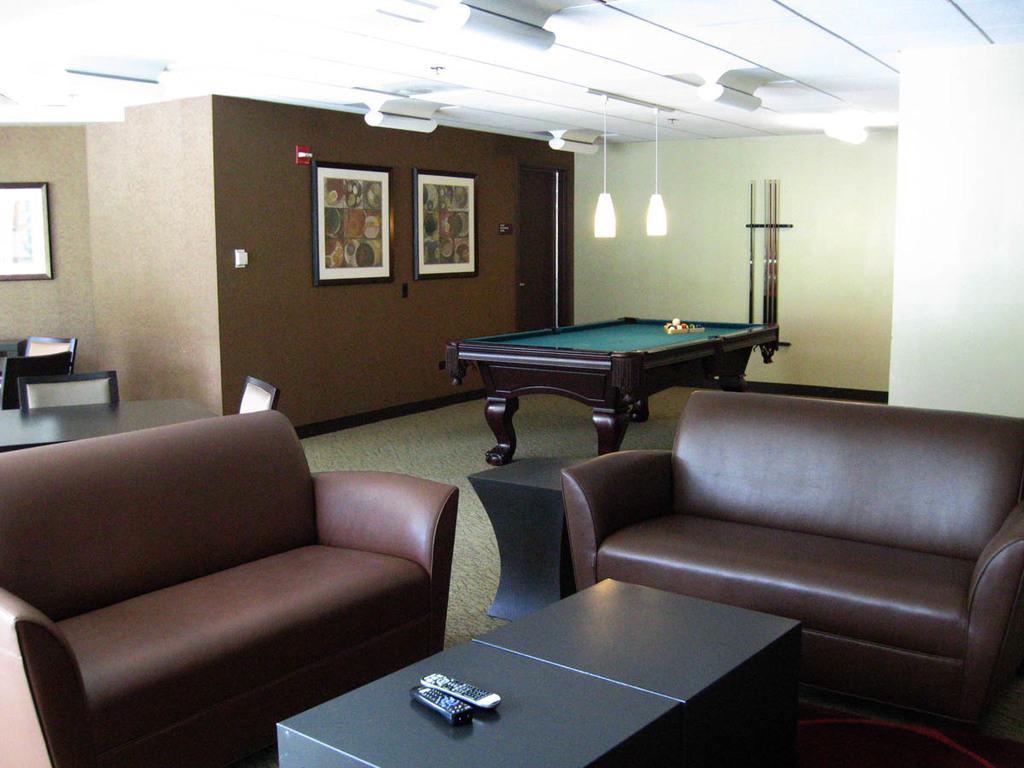How would you summarize this image in a sentence or two? In the center of the image there is a table. On the table there are different color ball. On the bottom there is a remote , which in black color and another one in a white color. There are two couches which in a brown color. On the background we can see two frames was attached to a wall. On the left side we can see a chairs. 